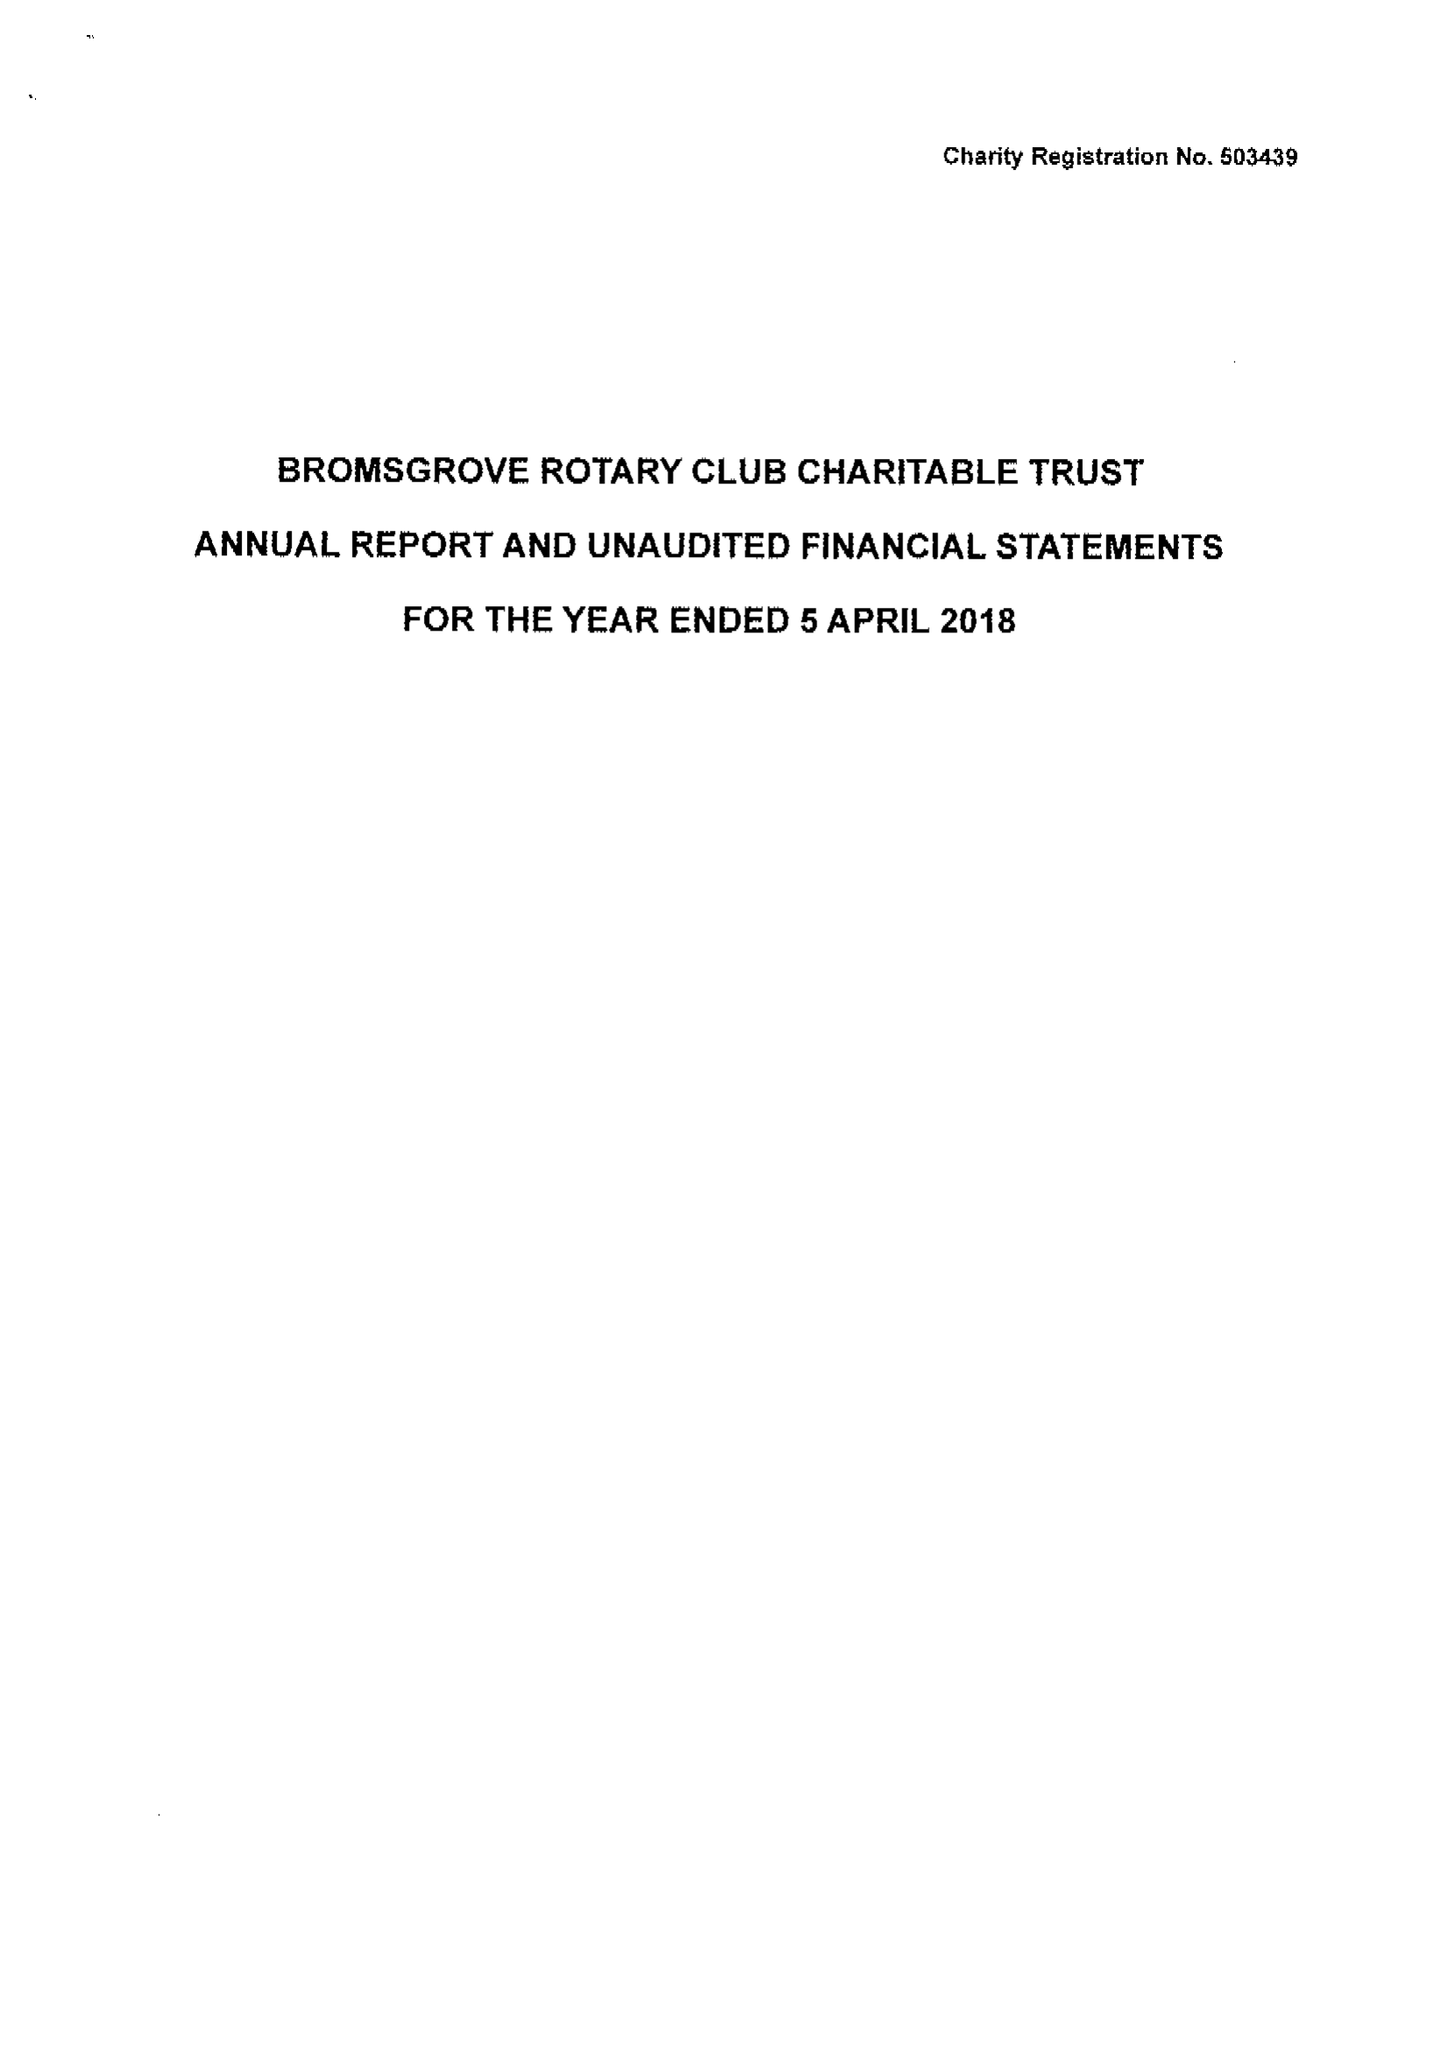What is the value for the report_date?
Answer the question using a single word or phrase. 2018-04-05 